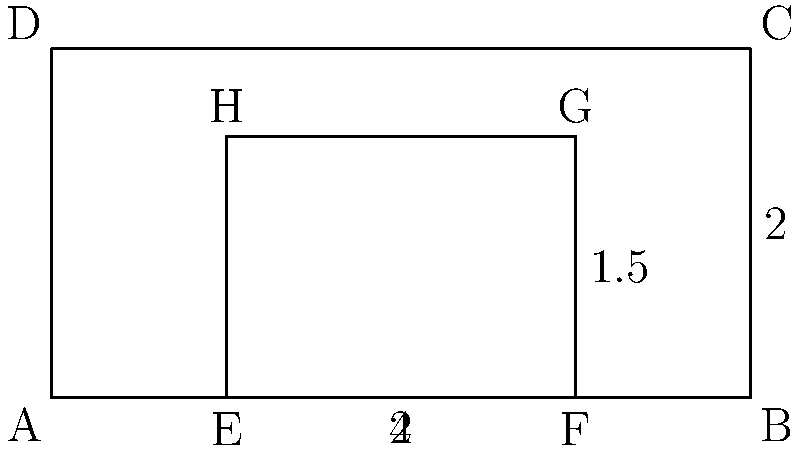In a study of automotive aerodynamics, two simplified car shapes are represented by rectangles ABCD and EFGH. Rectangle ABCD represents a boxy, traditional car design, while EFGH represents a more streamlined, modern design. If the drag coefficient is inversely proportional to the ratio of the car's length to its height, calculate the percentage improvement in aerodynamic efficiency of the modern design (EFGH) compared to the traditional design (ABCD). To solve this problem, we'll follow these steps:

1. Calculate the length-to-height ratio for each car design:

   For ABCD (traditional design):
   Length = 4 units
   Height = 2 units
   Ratio = $\frac{4}{2} = 2$

   For EFGH (modern design):
   Length = 2 units
   Height = 1.5 units
   Ratio = $\frac{2}{1.5} = \frac{4}{3} \approx 1.33$

2. Since the drag coefficient is inversely proportional to the length-to-height ratio, we can express it as:

   $C_d \propto \frac{1}{\text{ratio}}$

3. To compare the two designs, we'll use the ratio of their drag coefficients:

   $\frac{C_{d,\text{modern}}}{C_{d,\text{traditional}}} = \frac{\frac{1}{\text{ratio}_\text{modern}}}{\frac{1}{\text{ratio}_\text{traditional}}} = \frac{\text{ratio}_\text{traditional}}{\text{ratio}_\text{modern}}$

4. Plug in the values:

   $\frac{C_{d,\text{modern}}}{C_{d,\text{traditional}}} = \frac{2}{\frac{4}{3}} = \frac{2 \times 3}{4} = \frac{3}{2} = 1.5$

5. Calculate the percentage improvement:

   Improvement = $(1 - \frac{C_{d,\text{modern}}}{C_{d,\text{traditional}}}) \times 100\%$
                = $(1 - 1.5) \times 100\%$
                = $-0.5 \times 100\%$
                = $-50\%$

The negative value indicates that the modern design is actually less aerodynamically efficient according to this simplified model.

6. To express this as a percentage improvement of the modern design over the traditional design, we need to reverse the sign:

   Percentage improvement = $50\%$
Answer: 50% 